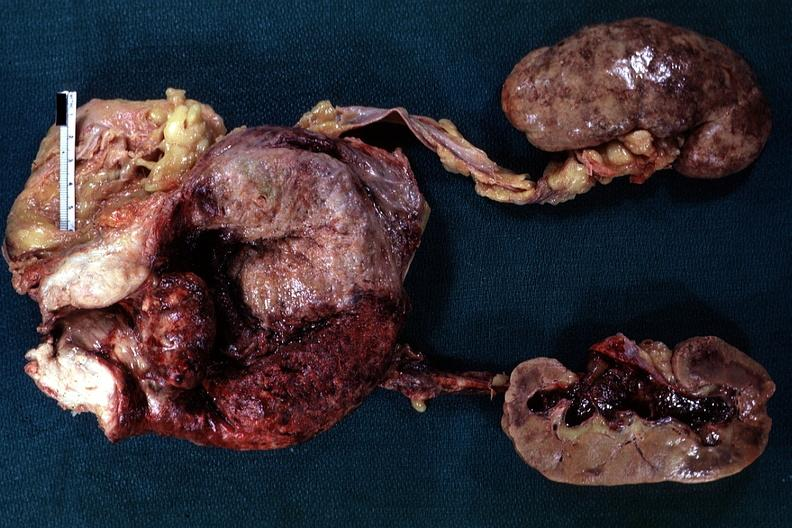s hyperplasia median bar present?
Answer the question using a single word or phrase. Yes 